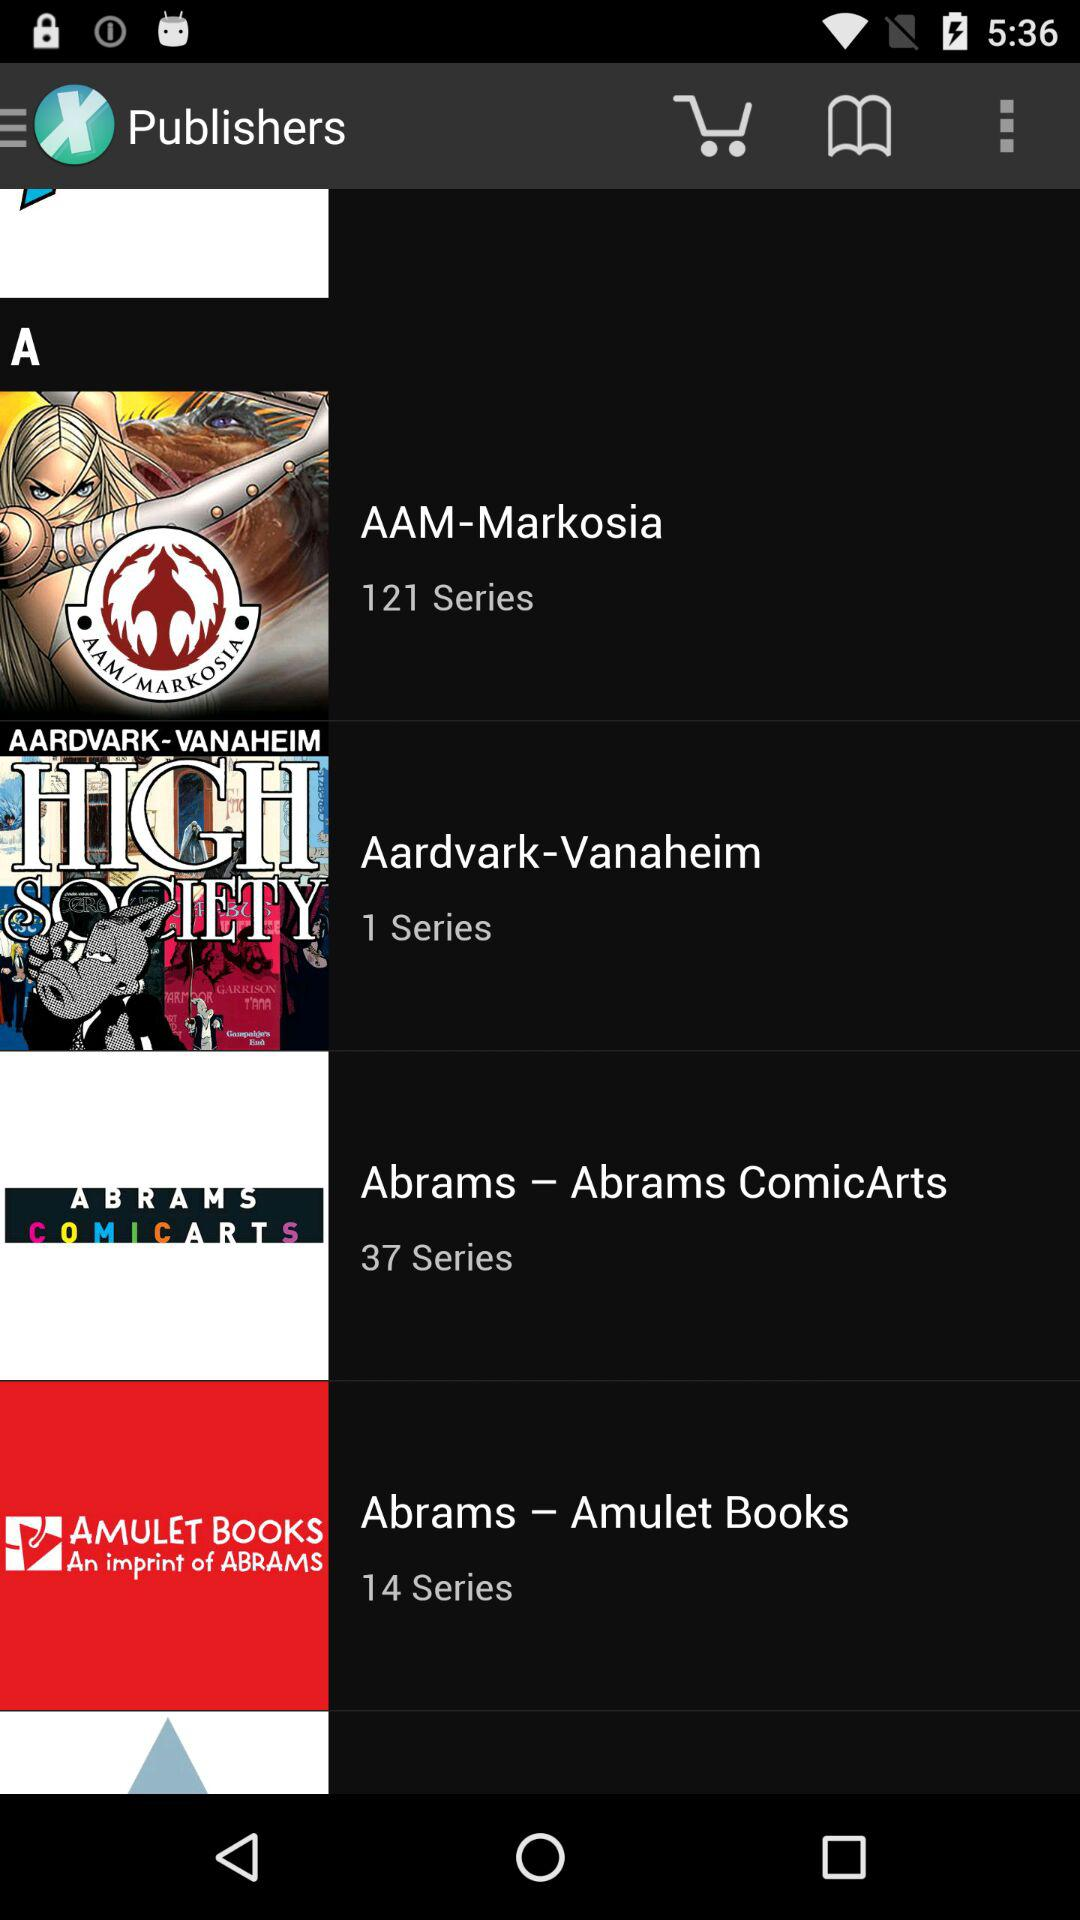What is the number of series of the Publisher Abrams - Amulet books? The total number of series is 14. 